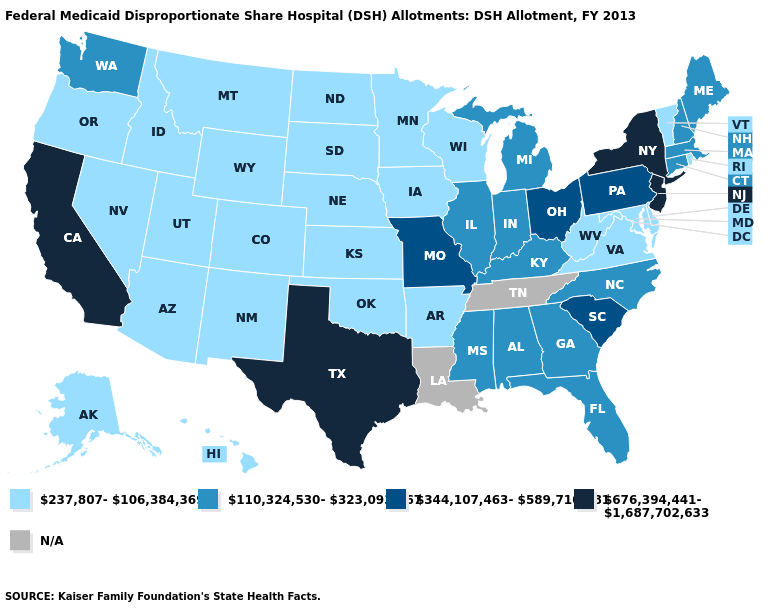Name the states that have a value in the range 237,807-106,384,369?
Be succinct. Alaska, Arizona, Arkansas, Colorado, Delaware, Hawaii, Idaho, Iowa, Kansas, Maryland, Minnesota, Montana, Nebraska, Nevada, New Mexico, North Dakota, Oklahoma, Oregon, Rhode Island, South Dakota, Utah, Vermont, Virginia, West Virginia, Wisconsin, Wyoming. What is the value of Ohio?
Write a very short answer. 344,107,463-589,710,881. What is the value of Tennessee?
Quick response, please. N/A. How many symbols are there in the legend?
Be succinct. 5. How many symbols are there in the legend?
Answer briefly. 5. Which states hav the highest value in the Northeast?
Keep it brief. New Jersey, New York. Name the states that have a value in the range 344,107,463-589,710,881?
Give a very brief answer. Missouri, Ohio, Pennsylvania, South Carolina. What is the highest value in the South ?
Give a very brief answer. 676,394,441-1,687,702,633. What is the value of Utah?
Quick response, please. 237,807-106,384,369. Among the states that border Nevada , does Utah have the highest value?
Short answer required. No. Which states hav the highest value in the Northeast?
Concise answer only. New Jersey, New York. Name the states that have a value in the range 344,107,463-589,710,881?
Keep it brief. Missouri, Ohio, Pennsylvania, South Carolina. Name the states that have a value in the range N/A?
Be succinct. Louisiana, Tennessee. What is the lowest value in the USA?
Short answer required. 237,807-106,384,369. Name the states that have a value in the range 237,807-106,384,369?
Write a very short answer. Alaska, Arizona, Arkansas, Colorado, Delaware, Hawaii, Idaho, Iowa, Kansas, Maryland, Minnesota, Montana, Nebraska, Nevada, New Mexico, North Dakota, Oklahoma, Oregon, Rhode Island, South Dakota, Utah, Vermont, Virginia, West Virginia, Wisconsin, Wyoming. 